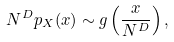Convert formula to latex. <formula><loc_0><loc_0><loc_500><loc_500>N ^ { D } p _ { X } ( x ) \sim g \left ( \frac { x } { N ^ { D } } \right ) ,</formula> 